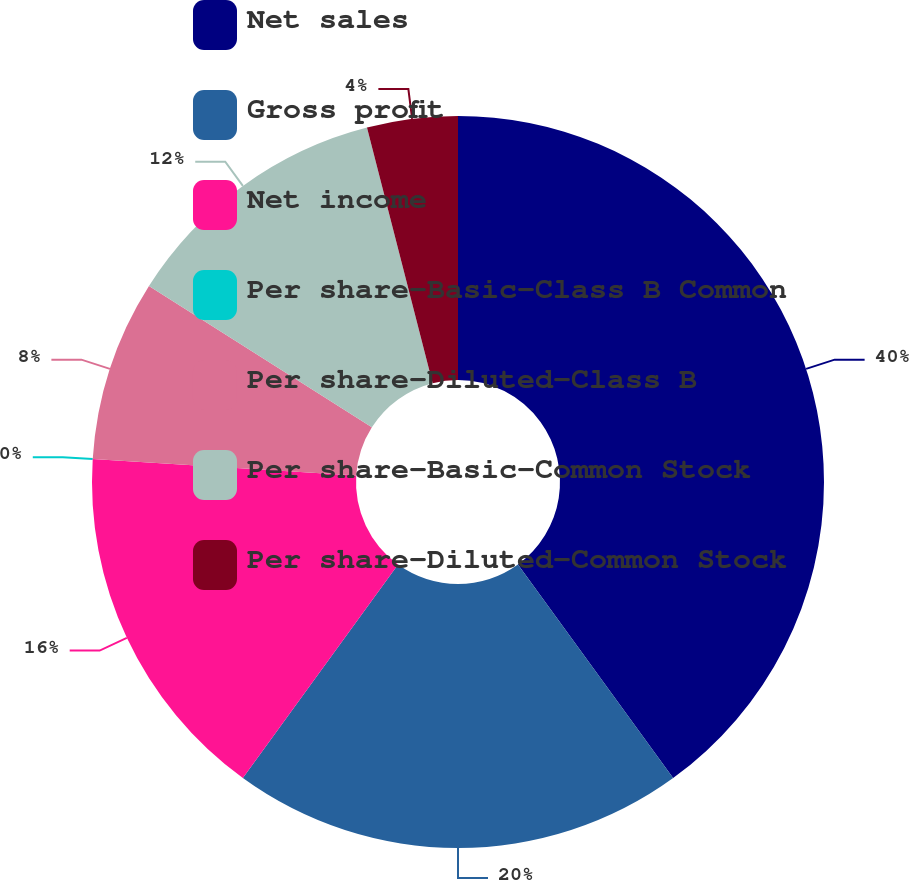Convert chart to OTSL. <chart><loc_0><loc_0><loc_500><loc_500><pie_chart><fcel>Net sales<fcel>Gross profit<fcel>Net income<fcel>Per share-Basic-Class B Common<fcel>Per share-Diluted-Class B<fcel>Per share-Basic-Common Stock<fcel>Per share-Diluted-Common Stock<nl><fcel>40.0%<fcel>20.0%<fcel>16.0%<fcel>0.0%<fcel>8.0%<fcel>12.0%<fcel>4.0%<nl></chart> 